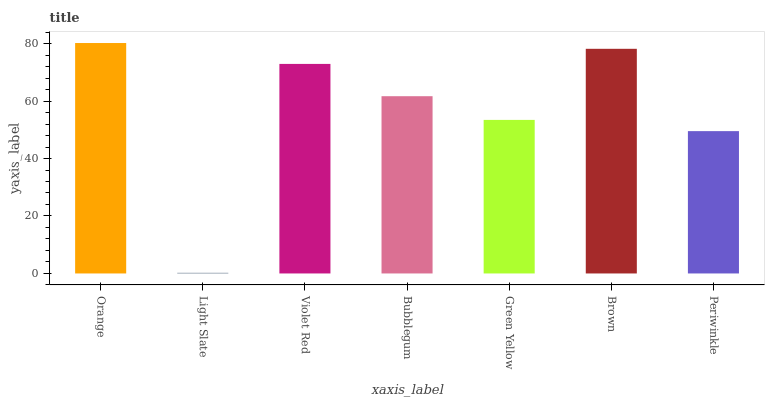Is Light Slate the minimum?
Answer yes or no. Yes. Is Orange the maximum?
Answer yes or no. Yes. Is Violet Red the minimum?
Answer yes or no. No. Is Violet Red the maximum?
Answer yes or no. No. Is Violet Red greater than Light Slate?
Answer yes or no. Yes. Is Light Slate less than Violet Red?
Answer yes or no. Yes. Is Light Slate greater than Violet Red?
Answer yes or no. No. Is Violet Red less than Light Slate?
Answer yes or no. No. Is Bubblegum the high median?
Answer yes or no. Yes. Is Bubblegum the low median?
Answer yes or no. Yes. Is Orange the high median?
Answer yes or no. No. Is Light Slate the low median?
Answer yes or no. No. 